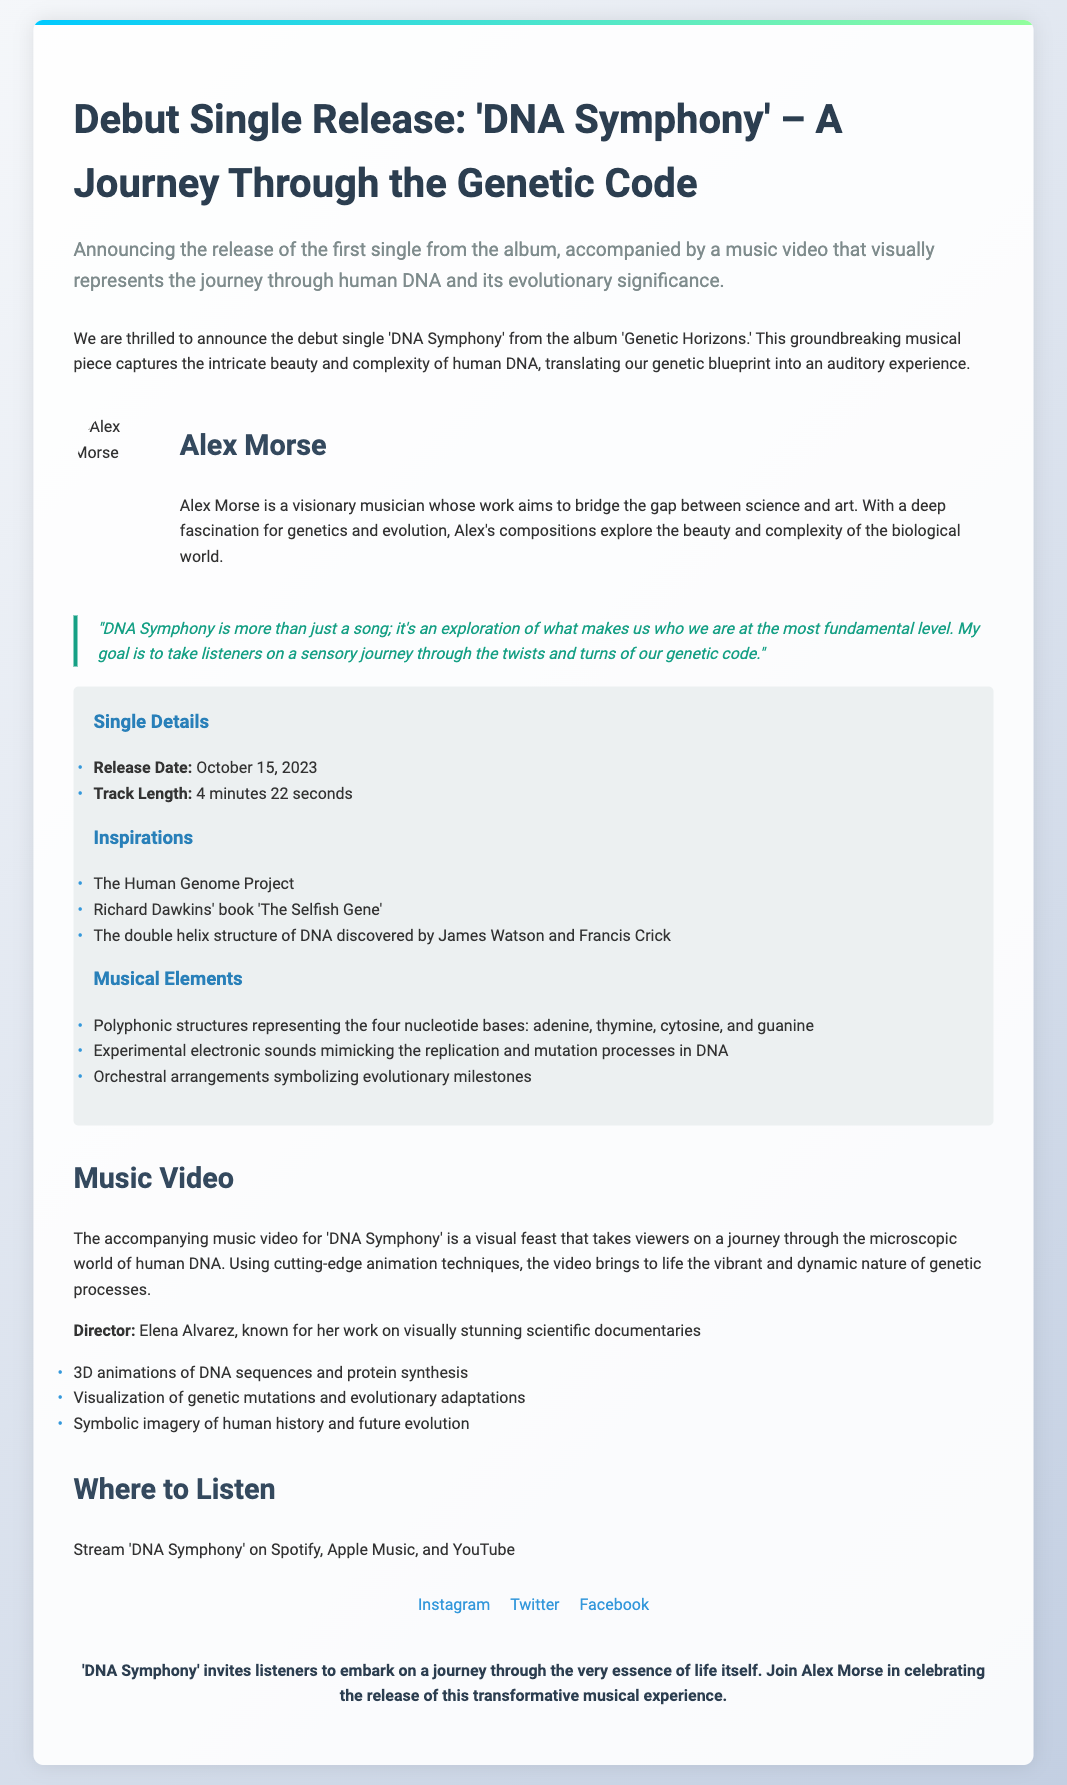What is the title of the debut single? The title of the debut single is mentioned in the heading of the press release.
Answer: DNA Symphony Who is the artist behind 'DNA Symphony'? The artist's name is provided in the artist information section.
Answer: Alex Morse When was 'DNA Symphony' released? The release date is specified in the single details.
Answer: October 15, 2023 What is the track length of 'DNA Symphony'? The track length is derived from the single details section of the document.
Answer: 4 minutes 22 seconds What project inspired Alex Morse's music? This information is found in the inspirations section of the details.
Answer: The Human Genome Project How does 'DNA Symphony' represent the genetic code musically? This question requires understanding of the described musical elements across multiple sections.
Answer: Polyphonic structures Who directed the music video for 'DNA Symphony'? The director's name is mentioned in the music video section.
Answer: Elena Alvarez Where can listeners stream 'DNA Symphony'? The streaming platforms are outlined in the where to listen section.
Answer: Spotify, Apple Music, and YouTube What type of animation is used in the music video? This is specified in the description of the music video content.
Answer: 3D animations What is the overarching theme of 'DNA Symphony'? This theme is articulated in the closing statement of the press release.
Answer: The essence of life itself 